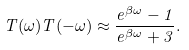<formula> <loc_0><loc_0><loc_500><loc_500>T ( \omega ) T ( - \omega ) \approx \frac { e ^ { \beta \omega } - 1 } { e ^ { \beta \omega } + 3 } .</formula> 